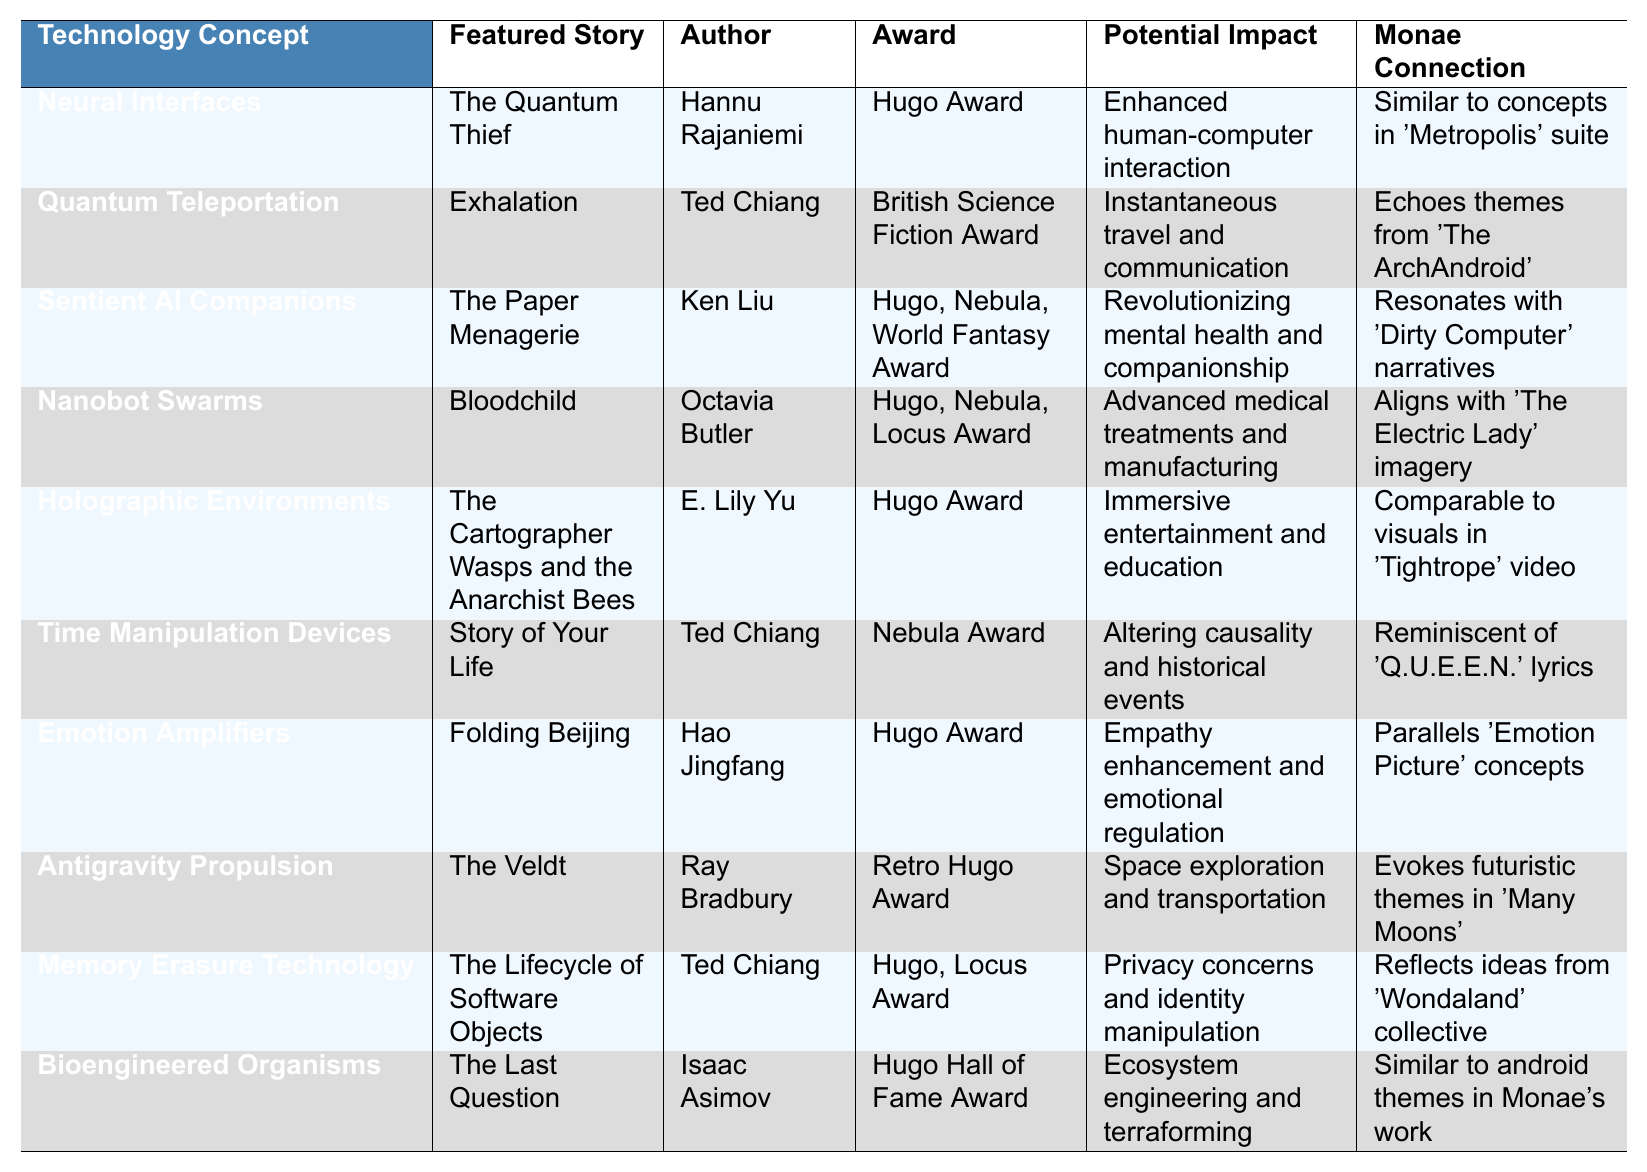What is the technology concept associated with "The Paper Menagerie"? According to the table, the technology concept related to "The Paper Menagerie" is "Sentient AI Companions".
Answer: Sentient AI Companions Which author received an award for "Time Manipulation Devices"? The table indicates that "Time Manipulation Devices" is featured in "Story of Your Life" by Ted Chiang, who received a Nebula Award.
Answer: Ted Chiang What potential impact is linked to Holographic Environments? The table shows that Holographic Environments have the potential impact of "Immersive entertainment and education".
Answer: Immersive entertainment and education Is "Memory Erasure Technology" associated with a Hugo Award? The table states that "Memory Erasure Technology" listed under "The Lifecycle of Software Objects" won the Hugo Award. Thus, the answer is yes.
Answer: Yes Which technology concept resonates with "Dirty Computer" narratives? The table indicates that "Sentient AI Companions" is the technology concept that resonates with "Dirty Computer" narratives as per its Monae connection.
Answer: Sentient AI Companions How many technology concepts mentioned in the table are associated with Ted Chiang? From the table, Ted Chiang is associated with three technology concepts: "Quantum Teleportation", "Sentient AI Companions", and "Time Manipulation Devices". Therefore, the count is 3.
Answer: 3 Which author has the most featured stories in the table? By examining the table, Ted Chiang is featured three times for different stories, which is more than any other author.
Answer: Ted Chiang What are the awards associated with "The Last Question"? According to the table, "The Last Question" by Isaac Asimov has won the Hugo Hall of Fame Award.
Answer: Hugo Hall of Fame Award What potential impact is related to Emotion Amplifiers? The table shows that Emotion Amplifiers are linked to the potential impact of "Empathy enhancement and emotional regulation".
Answer: Empathy enhancement and emotional regulation Which technology concept corresponds with the award-winning "The Lifecycle of Software Objects"? The technology concept tied to "The Lifecycle of Software Objects" is "Memory Erasure Technology", which won a Hugo Award.
Answer: Memory Erasure Technology 